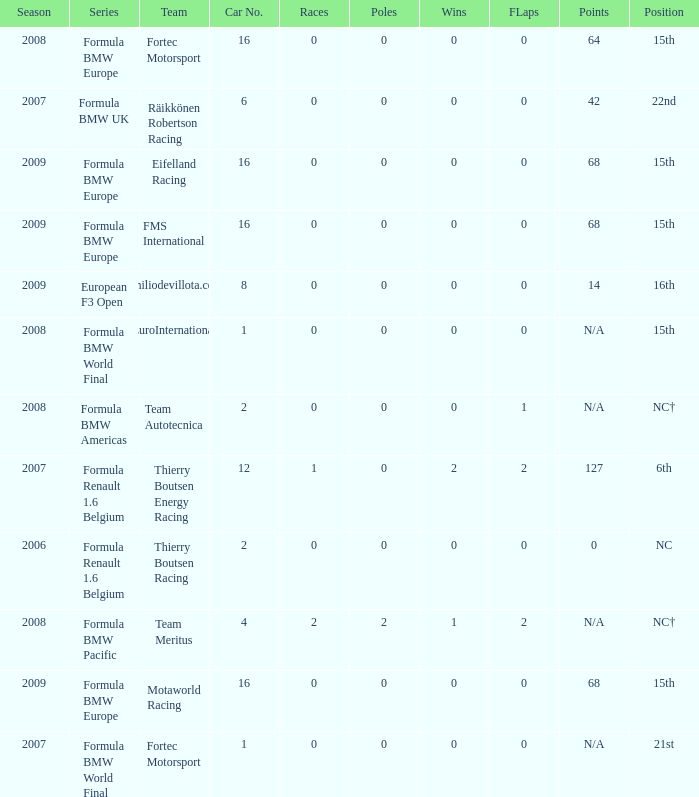Name the series for 68 Formula BMW Europe, Formula BMW Europe, Formula BMW Europe. 